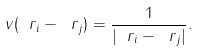<formula> <loc_0><loc_0><loc_500><loc_500>v ( \ r _ { i } - \ r _ { j } ) = \frac { 1 } { | \ r _ { i } - \ r _ { j } | } .</formula> 